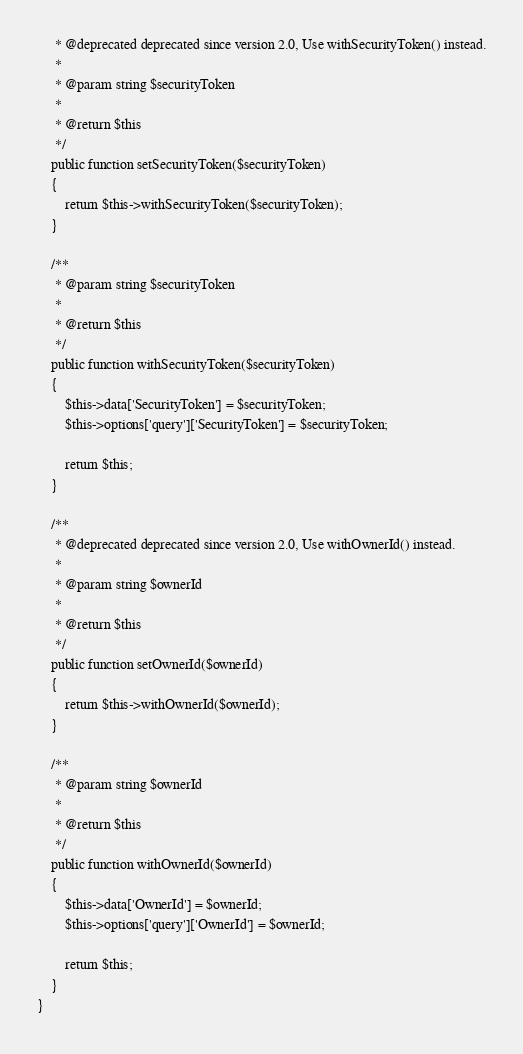<code> <loc_0><loc_0><loc_500><loc_500><_PHP_>     * @deprecated deprecated since version 2.0, Use withSecurityToken() instead.
     *
     * @param string $securityToken
     *
     * @return $this
     */
    public function setSecurityToken($securityToken)
    {
        return $this->withSecurityToken($securityToken);
    }

    /**
     * @param string $securityToken
     *
     * @return $this
     */
    public function withSecurityToken($securityToken)
    {
        $this->data['SecurityToken'] = $securityToken;
        $this->options['query']['SecurityToken'] = $securityToken;

        return $this;
    }

    /**
     * @deprecated deprecated since version 2.0, Use withOwnerId() instead.
     *
     * @param string $ownerId
     *
     * @return $this
     */
    public function setOwnerId($ownerId)
    {
        return $this->withOwnerId($ownerId);
    }

    /**
     * @param string $ownerId
     *
     * @return $this
     */
    public function withOwnerId($ownerId)
    {
        $this->data['OwnerId'] = $ownerId;
        $this->options['query']['OwnerId'] = $ownerId;

        return $this;
    }
}
</code> 